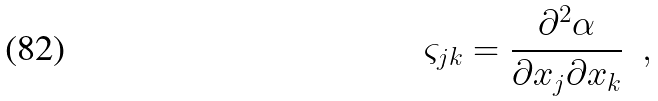<formula> <loc_0><loc_0><loc_500><loc_500>\varsigma _ { j k } = \frac { \partial ^ { 2 } \alpha } { \partial x _ { j } \partial x _ { k } } \ \ ,</formula> 